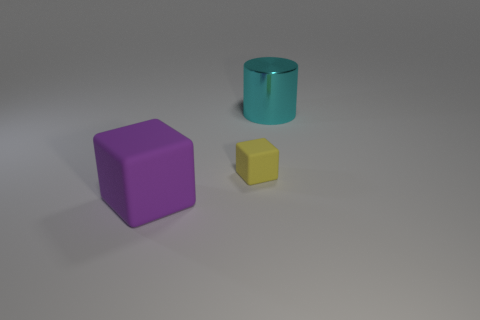Are there any other things that are the same material as the cyan cylinder?
Offer a very short reply. No. Is the shiny cylinder the same size as the purple matte object?
Provide a succinct answer. Yes. How many things are purple matte things or things behind the purple object?
Ensure brevity in your answer.  3. What number of things are either blocks that are right of the large rubber block or rubber things behind the big purple matte block?
Offer a very short reply. 1. Are there any cyan metal objects behind the big block?
Give a very brief answer. Yes. What is the color of the large object on the right side of the matte object that is in front of the rubber cube right of the large cube?
Your response must be concise. Cyan. Is the shape of the big matte object the same as the small yellow thing?
Make the answer very short. Yes. There is another cube that is the same material as the yellow block; what color is it?
Offer a very short reply. Purple. How many things are either things that are in front of the cyan cylinder or big metal things?
Provide a short and direct response. 3. How big is the purple matte cube on the left side of the yellow object?
Keep it short and to the point. Large. 